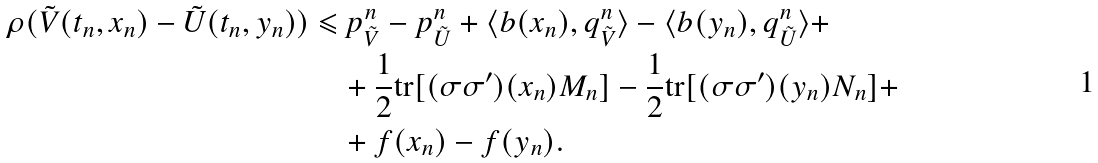<formula> <loc_0><loc_0><loc_500><loc_500>\rho ( \tilde { V } ( t _ { n } , x _ { n } ) - \tilde { U } ( t _ { n } , y _ { n } ) ) \leqslant & \, p _ { \tilde { V } } ^ { n } - p _ { \tilde { U } } ^ { n } + \langle b ( x _ { n } ) , q _ { \tilde { V } } ^ { n } \rangle - \langle b ( y _ { n } ) , q _ { \tilde { U } } ^ { n } \rangle + \\ & + \frac { 1 } { 2 } \text {tr} [ ( \sigma \sigma ^ { \prime } ) ( x _ { n } ) M _ { n } ] - \frac { 1 } { 2 } \text {tr} [ ( \sigma \sigma ^ { \prime } ) ( y _ { n } ) N _ { n } ] + \\ & + f ( x _ { n } ) - f ( y _ { n } ) .</formula> 